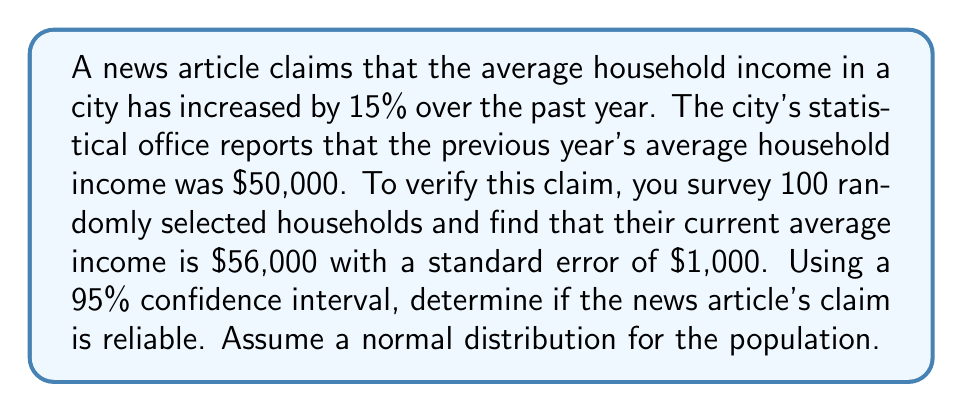What is the answer to this math problem? To analyze the reliability of the statistical claim, we'll follow these steps:

1. Calculate the claimed new average income:
   $50,000 \times 1.15 = $57,500$

2. Determine the margin of error using the standard error and the z-score for a 95% confidence interval:
   Margin of Error = $z \times SE$
   For 95% CI, $z = 1.96$
   $ME = 1.96 \times $1,000 = $1,960$

3. Calculate the confidence interval:
   $CI = \bar{x} \pm ME$
   $CI = $56,000 \pm $1,960$
   Lower bound: $56,000 - $1,960 = $54,040$
   Upper bound: $56,000 + $1,960 = $57,960$

4. Compare the claimed value to the confidence interval:
   The claimed value ($57,500) falls within the confidence interval [$54,040, $57,960].

5. Interpret the results:
   Since the claimed value falls within the 95% confidence interval, we cannot reject the news article's claim as unreliable based on our sample data.

6. Calculate the percentage difference between the sample mean and the claimed value:
   Difference = $\frac{|57,500 - 56,000|}{56,000} \times 100\% = 2.68\%$

This small difference further supports the reliability of the claim, given the sample size and variability.
Answer: The claim is reliable within the 95% confidence interval. 